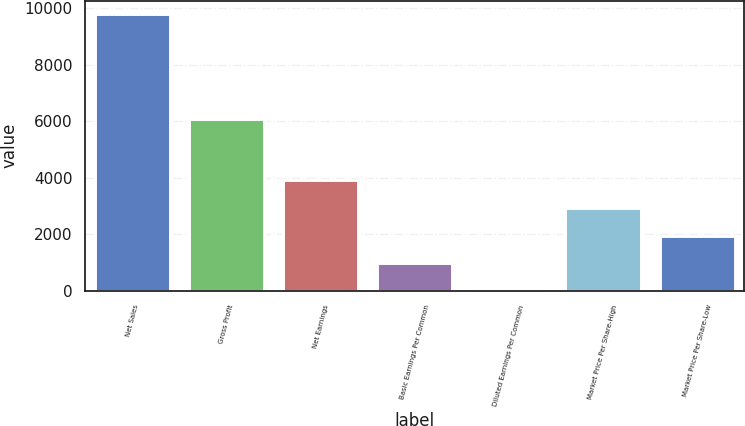<chart> <loc_0><loc_0><loc_500><loc_500><bar_chart><fcel>Net Sales<fcel>Gross Profit<fcel>Net Earnings<fcel>Basic Earnings Per Common<fcel>Diluted Earnings Per Common<fcel>Market Price Per Share-High<fcel>Market Price Per Share-Low<nl><fcel>9773.3<fcel>6075.2<fcel>3910.05<fcel>978.42<fcel>1.21<fcel>2932.84<fcel>1955.63<nl></chart> 